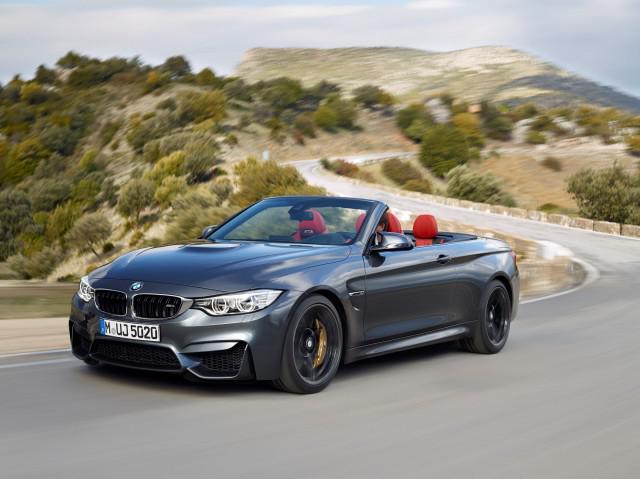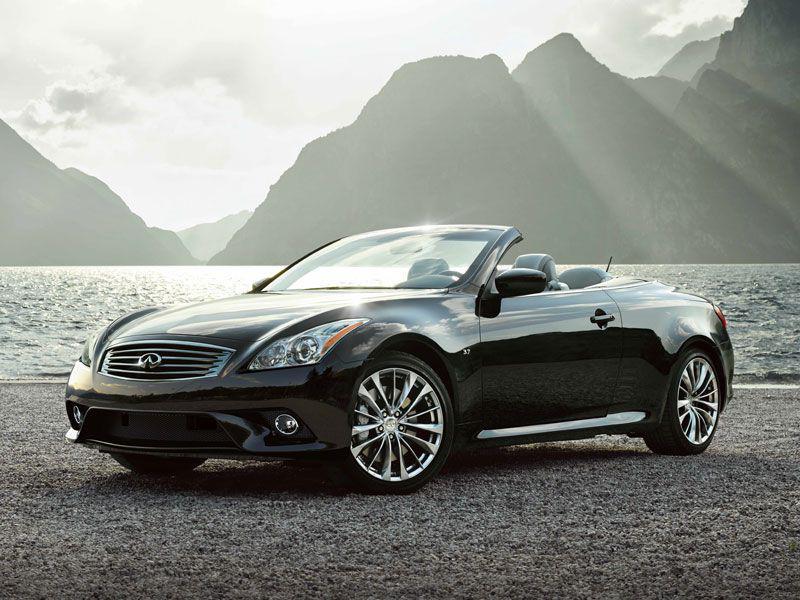The first image is the image on the left, the second image is the image on the right. Evaluate the accuracy of this statement regarding the images: "The cars in the left and right images are each turned leftward, and one car is pictured in front of water and peaks of land.". Is it true? Answer yes or no. Yes. 